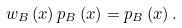<formula> <loc_0><loc_0><loc_500><loc_500>w _ { B } \left ( x \right ) p _ { B } \left ( x \right ) = p _ { B } \left ( x \right ) .</formula> 